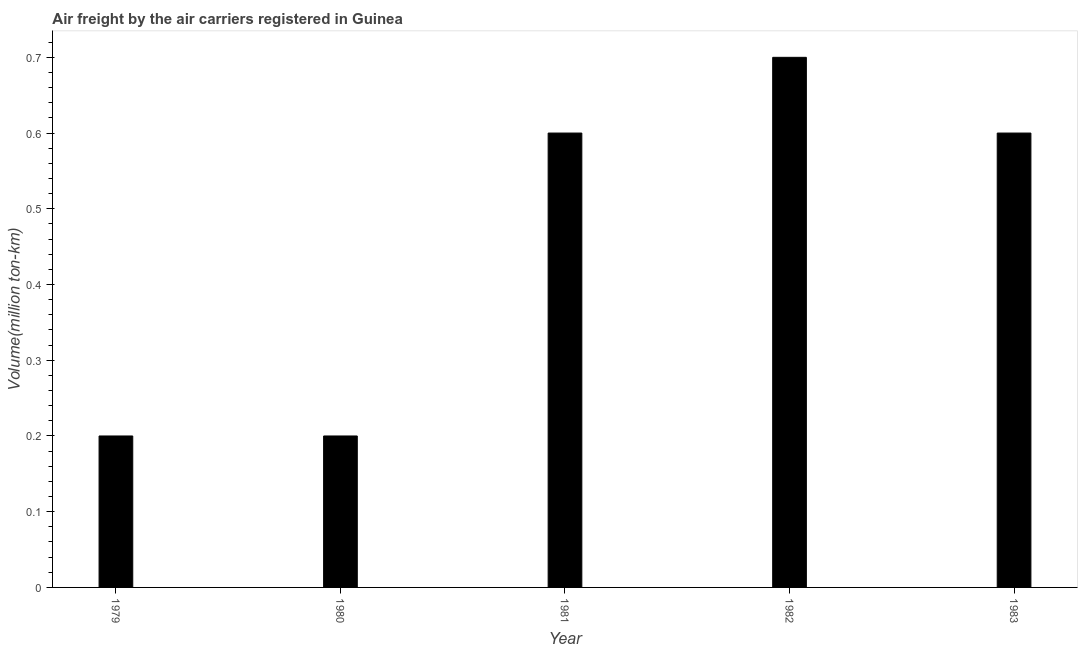Does the graph contain any zero values?
Provide a short and direct response. No. What is the title of the graph?
Provide a short and direct response. Air freight by the air carriers registered in Guinea. What is the label or title of the X-axis?
Keep it short and to the point. Year. What is the label or title of the Y-axis?
Make the answer very short. Volume(million ton-km). What is the air freight in 1981?
Your response must be concise. 0.6. Across all years, what is the maximum air freight?
Offer a very short reply. 0.7. Across all years, what is the minimum air freight?
Give a very brief answer. 0.2. In which year was the air freight minimum?
Keep it short and to the point. 1979. What is the sum of the air freight?
Offer a very short reply. 2.3. What is the difference between the air freight in 1979 and 1980?
Your answer should be compact. 0. What is the average air freight per year?
Your answer should be compact. 0.46. What is the median air freight?
Offer a terse response. 0.6. Do a majority of the years between 1982 and 1983 (inclusive) have air freight greater than 0.6 million ton-km?
Provide a succinct answer. Yes. What is the ratio of the air freight in 1981 to that in 1983?
Keep it short and to the point. 1. Is the air freight in 1979 less than that in 1983?
Keep it short and to the point. Yes. Is the difference between the air freight in 1980 and 1982 greater than the difference between any two years?
Your response must be concise. Yes. What is the difference between the highest and the second highest air freight?
Keep it short and to the point. 0.1. Is the sum of the air freight in 1981 and 1982 greater than the maximum air freight across all years?
Offer a very short reply. Yes. What is the difference between the highest and the lowest air freight?
Provide a short and direct response. 0.5. In how many years, is the air freight greater than the average air freight taken over all years?
Offer a terse response. 3. How many bars are there?
Your response must be concise. 5. Are all the bars in the graph horizontal?
Provide a succinct answer. No. How many years are there in the graph?
Provide a short and direct response. 5. What is the difference between two consecutive major ticks on the Y-axis?
Offer a terse response. 0.1. Are the values on the major ticks of Y-axis written in scientific E-notation?
Your answer should be very brief. No. What is the Volume(million ton-km) of 1979?
Provide a succinct answer. 0.2. What is the Volume(million ton-km) of 1980?
Your answer should be very brief. 0.2. What is the Volume(million ton-km) of 1981?
Offer a terse response. 0.6. What is the Volume(million ton-km) of 1982?
Give a very brief answer. 0.7. What is the Volume(million ton-km) in 1983?
Your answer should be very brief. 0.6. What is the difference between the Volume(million ton-km) in 1979 and 1983?
Provide a succinct answer. -0.4. What is the difference between the Volume(million ton-km) in 1980 and 1981?
Keep it short and to the point. -0.4. What is the difference between the Volume(million ton-km) in 1980 and 1983?
Keep it short and to the point. -0.4. What is the difference between the Volume(million ton-km) in 1981 and 1982?
Your answer should be compact. -0.1. What is the difference between the Volume(million ton-km) in 1981 and 1983?
Provide a short and direct response. 0. What is the difference between the Volume(million ton-km) in 1982 and 1983?
Keep it short and to the point. 0.1. What is the ratio of the Volume(million ton-km) in 1979 to that in 1980?
Offer a terse response. 1. What is the ratio of the Volume(million ton-km) in 1979 to that in 1981?
Provide a short and direct response. 0.33. What is the ratio of the Volume(million ton-km) in 1979 to that in 1982?
Give a very brief answer. 0.29. What is the ratio of the Volume(million ton-km) in 1979 to that in 1983?
Ensure brevity in your answer.  0.33. What is the ratio of the Volume(million ton-km) in 1980 to that in 1981?
Make the answer very short. 0.33. What is the ratio of the Volume(million ton-km) in 1980 to that in 1982?
Your response must be concise. 0.29. What is the ratio of the Volume(million ton-km) in 1980 to that in 1983?
Keep it short and to the point. 0.33. What is the ratio of the Volume(million ton-km) in 1981 to that in 1982?
Ensure brevity in your answer.  0.86. What is the ratio of the Volume(million ton-km) in 1982 to that in 1983?
Give a very brief answer. 1.17. 